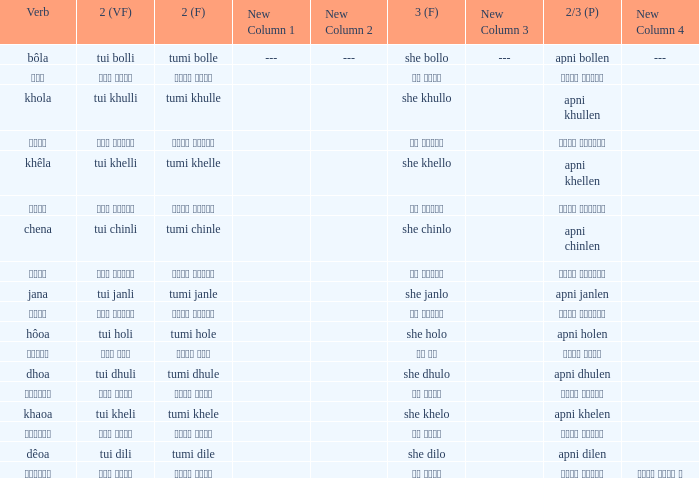What is the 2nd verb for Khola? Tumi khulle. 